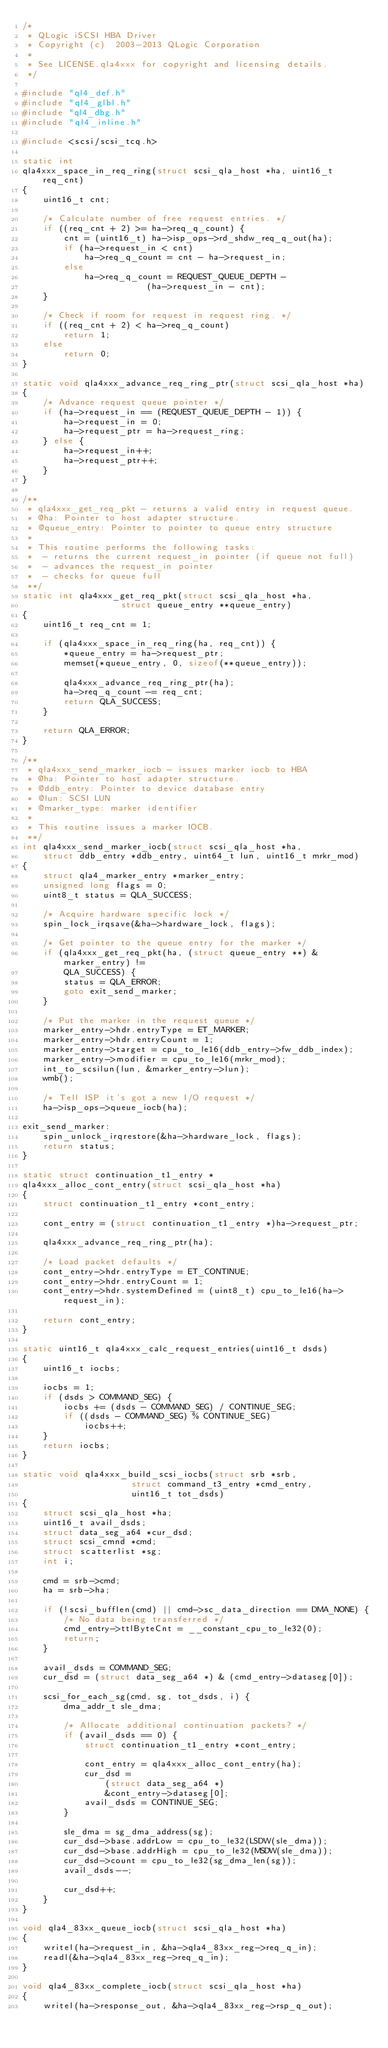Convert code to text. <code><loc_0><loc_0><loc_500><loc_500><_C_>/*
 * QLogic iSCSI HBA Driver
 * Copyright (c)  2003-2013 QLogic Corporation
 *
 * See LICENSE.qla4xxx for copyright and licensing details.
 */

#include "ql4_def.h"
#include "ql4_glbl.h"
#include "ql4_dbg.h"
#include "ql4_inline.h"

#include <scsi/scsi_tcq.h>

static int
qla4xxx_space_in_req_ring(struct scsi_qla_host *ha, uint16_t req_cnt)
{
	uint16_t cnt;

	/* Calculate number of free request entries. */
	if ((req_cnt + 2) >= ha->req_q_count) {
		cnt = (uint16_t) ha->isp_ops->rd_shdw_req_q_out(ha);
		if (ha->request_in < cnt)
			ha->req_q_count = cnt - ha->request_in;
		else
			ha->req_q_count = REQUEST_QUEUE_DEPTH -
						(ha->request_in - cnt);
	}

	/* Check if room for request in request ring. */
	if ((req_cnt + 2) < ha->req_q_count)
		return 1;
	else
		return 0;
}

static void qla4xxx_advance_req_ring_ptr(struct scsi_qla_host *ha)
{
	/* Advance request queue pointer */
	if (ha->request_in == (REQUEST_QUEUE_DEPTH - 1)) {
		ha->request_in = 0;
		ha->request_ptr = ha->request_ring;
	} else {
		ha->request_in++;
		ha->request_ptr++;
	}
}

/**
 * qla4xxx_get_req_pkt - returns a valid entry in request queue.
 * @ha: Pointer to host adapter structure.
 * @queue_entry: Pointer to pointer to queue entry structure
 *
 * This routine performs the following tasks:
 *	- returns the current request_in pointer (if queue not full)
 *	- advances the request_in pointer
 *	- checks for queue full
 **/
static int qla4xxx_get_req_pkt(struct scsi_qla_host *ha,
			       struct queue_entry **queue_entry)
{
	uint16_t req_cnt = 1;

	if (qla4xxx_space_in_req_ring(ha, req_cnt)) {
		*queue_entry = ha->request_ptr;
		memset(*queue_entry, 0, sizeof(**queue_entry));

		qla4xxx_advance_req_ring_ptr(ha);
		ha->req_q_count -= req_cnt;
		return QLA_SUCCESS;
	}

	return QLA_ERROR;
}

/**
 * qla4xxx_send_marker_iocb - issues marker iocb to HBA
 * @ha: Pointer to host adapter structure.
 * @ddb_entry: Pointer to device database entry
 * @lun: SCSI LUN
 * @marker_type: marker identifier
 *
 * This routine issues a marker IOCB.
 **/
int qla4xxx_send_marker_iocb(struct scsi_qla_host *ha,
	struct ddb_entry *ddb_entry, uint64_t lun, uint16_t mrkr_mod)
{
	struct qla4_marker_entry *marker_entry;
	unsigned long flags = 0;
	uint8_t status = QLA_SUCCESS;

	/* Acquire hardware specific lock */
	spin_lock_irqsave(&ha->hardware_lock, flags);

	/* Get pointer to the queue entry for the marker */
	if (qla4xxx_get_req_pkt(ha, (struct queue_entry **) &marker_entry) !=
	    QLA_SUCCESS) {
		status = QLA_ERROR;
		goto exit_send_marker;
	}

	/* Put the marker in the request queue */
	marker_entry->hdr.entryType = ET_MARKER;
	marker_entry->hdr.entryCount = 1;
	marker_entry->target = cpu_to_le16(ddb_entry->fw_ddb_index);
	marker_entry->modifier = cpu_to_le16(mrkr_mod);
	int_to_scsilun(lun, &marker_entry->lun);
	wmb();

	/* Tell ISP it's got a new I/O request */
	ha->isp_ops->queue_iocb(ha);

exit_send_marker:
	spin_unlock_irqrestore(&ha->hardware_lock, flags);
	return status;
}

static struct continuation_t1_entry *
qla4xxx_alloc_cont_entry(struct scsi_qla_host *ha)
{
	struct continuation_t1_entry *cont_entry;

	cont_entry = (struct continuation_t1_entry *)ha->request_ptr;

	qla4xxx_advance_req_ring_ptr(ha);

	/* Load packet defaults */
	cont_entry->hdr.entryType = ET_CONTINUE;
	cont_entry->hdr.entryCount = 1;
	cont_entry->hdr.systemDefined = (uint8_t) cpu_to_le16(ha->request_in);

	return cont_entry;
}

static uint16_t qla4xxx_calc_request_entries(uint16_t dsds)
{
	uint16_t iocbs;

	iocbs = 1;
	if (dsds > COMMAND_SEG) {
		iocbs += (dsds - COMMAND_SEG) / CONTINUE_SEG;
		if ((dsds - COMMAND_SEG) % CONTINUE_SEG)
			iocbs++;
	}
	return iocbs;
}

static void qla4xxx_build_scsi_iocbs(struct srb *srb,
				     struct command_t3_entry *cmd_entry,
				     uint16_t tot_dsds)
{
	struct scsi_qla_host *ha;
	uint16_t avail_dsds;
	struct data_seg_a64 *cur_dsd;
	struct scsi_cmnd *cmd;
	struct scatterlist *sg;
	int i;

	cmd = srb->cmd;
	ha = srb->ha;

	if (!scsi_bufflen(cmd) || cmd->sc_data_direction == DMA_NONE) {
		/* No data being transferred */
		cmd_entry->ttlByteCnt = __constant_cpu_to_le32(0);
		return;
	}

	avail_dsds = COMMAND_SEG;
	cur_dsd = (struct data_seg_a64 *) & (cmd_entry->dataseg[0]);

	scsi_for_each_sg(cmd, sg, tot_dsds, i) {
		dma_addr_t sle_dma;

		/* Allocate additional continuation packets? */
		if (avail_dsds == 0) {
			struct continuation_t1_entry *cont_entry;

			cont_entry = qla4xxx_alloc_cont_entry(ha);
			cur_dsd =
				(struct data_seg_a64 *)
				&cont_entry->dataseg[0];
			avail_dsds = CONTINUE_SEG;
		}

		sle_dma = sg_dma_address(sg);
		cur_dsd->base.addrLow = cpu_to_le32(LSDW(sle_dma));
		cur_dsd->base.addrHigh = cpu_to_le32(MSDW(sle_dma));
		cur_dsd->count = cpu_to_le32(sg_dma_len(sg));
		avail_dsds--;

		cur_dsd++;
	}
}

void qla4_83xx_queue_iocb(struct scsi_qla_host *ha)
{
	writel(ha->request_in, &ha->qla4_83xx_reg->req_q_in);
	readl(&ha->qla4_83xx_reg->req_q_in);
}

void qla4_83xx_complete_iocb(struct scsi_qla_host *ha)
{
	writel(ha->response_out, &ha->qla4_83xx_reg->rsp_q_out);</code> 